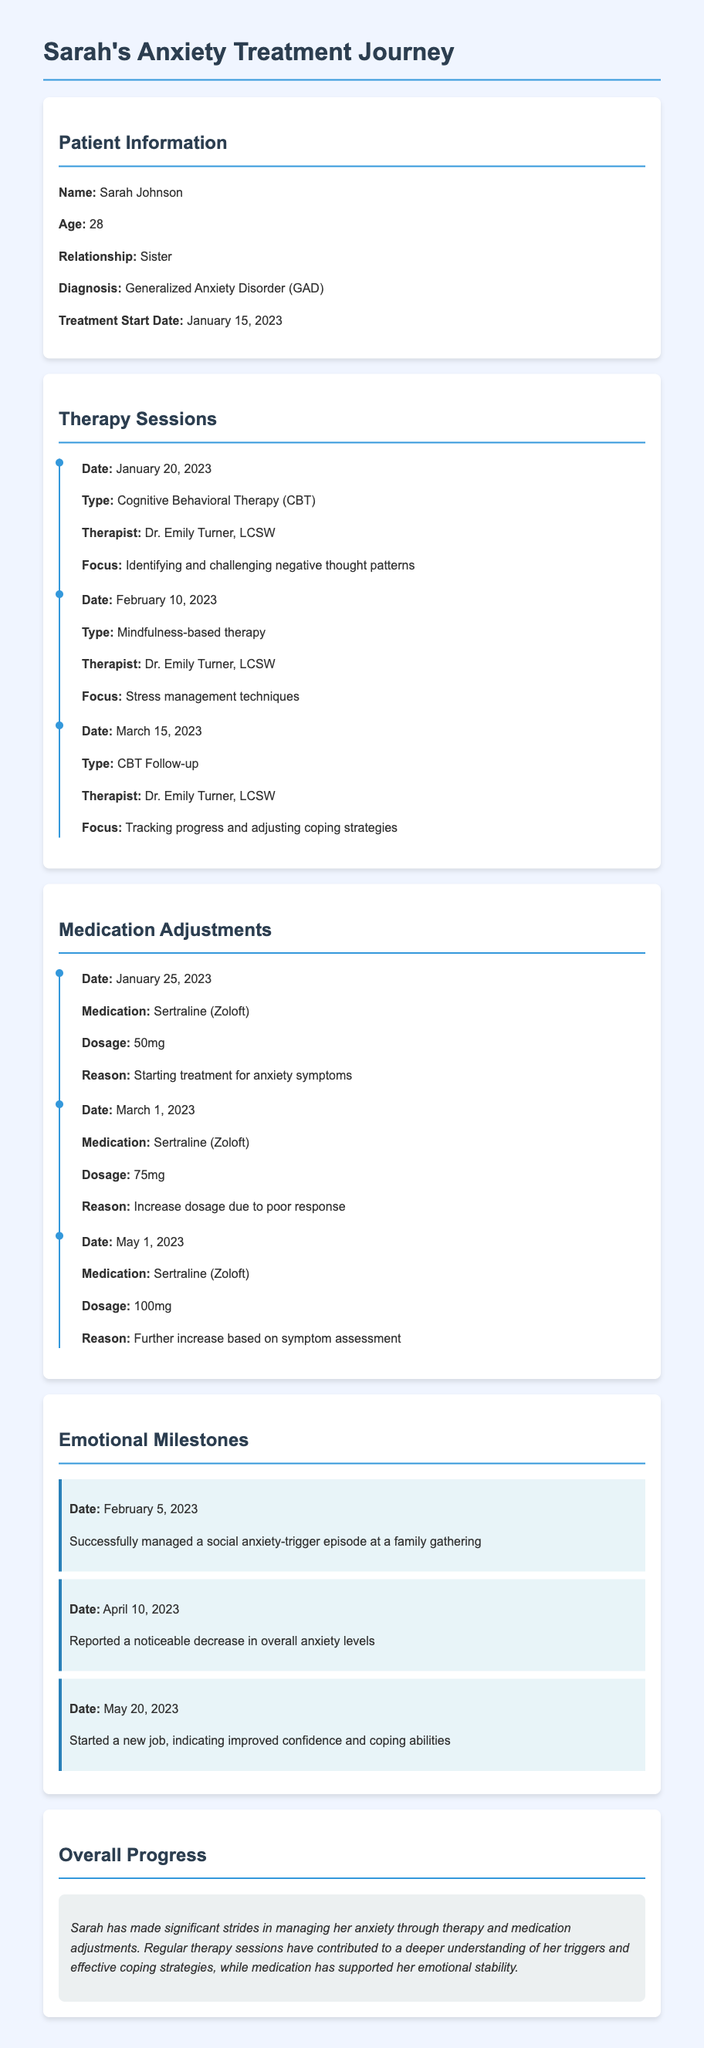What is the patient's name? The document provides the patient's full name in the Patient Information section.
Answer: Sarah Johnson What is the diagnosis? The document states the diagnosis in the Patient Information section.
Answer: Generalized Anxiety Disorder (GAD) When did treatment start? The start date of treatment is mentioned in the Patient Information section.
Answer: January 15, 2023 What type of therapy was first attended? The first therapy session listed provides the type of therapy received.
Answer: Cognitive Behavioral Therapy (CBT) What was the dosage of medication on March 1, 2023? The dosage for medication adjustments is detailed in the Medication Adjustments section.
Answer: 75mg What significant milestone was reached on May 20, 2023? The Emotional Milestones section lists important events, including the one on this date.
Answer: Started a new job Which therapist is mentioned in the document? The document specifies the name of the therapist in the Therapy Sessions section.
Answer: Dr. Emily Turner, LCSW What trend is noted in Sarah’s emotional status by April 10, 2023? The Emotional Milestones section indicates progress in emotional wellbeing on this date.
Answer: Noticeable decrease in overall anxiety levels How many therapy sessions are listed? A count of the therapy sessions can be derived from the Therapy Sessions section of the document.
Answer: Three 